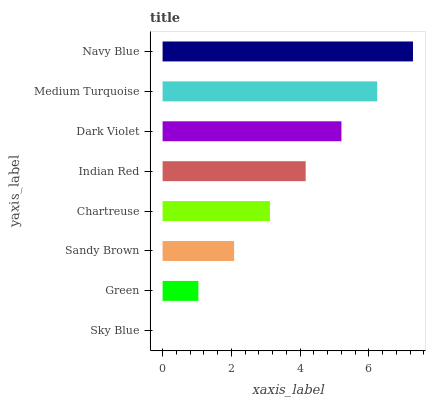Is Sky Blue the minimum?
Answer yes or no. Yes. Is Navy Blue the maximum?
Answer yes or no. Yes. Is Green the minimum?
Answer yes or no. No. Is Green the maximum?
Answer yes or no. No. Is Green greater than Sky Blue?
Answer yes or no. Yes. Is Sky Blue less than Green?
Answer yes or no. Yes. Is Sky Blue greater than Green?
Answer yes or no. No. Is Green less than Sky Blue?
Answer yes or no. No. Is Indian Red the high median?
Answer yes or no. Yes. Is Chartreuse the low median?
Answer yes or no. Yes. Is Dark Violet the high median?
Answer yes or no. No. Is Sandy Brown the low median?
Answer yes or no. No. 